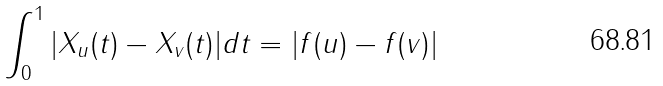<formula> <loc_0><loc_0><loc_500><loc_500>\int _ { 0 } ^ { 1 } | X _ { u } ( t ) - X _ { v } ( t ) | d t = | f ( u ) - f ( v ) |</formula> 